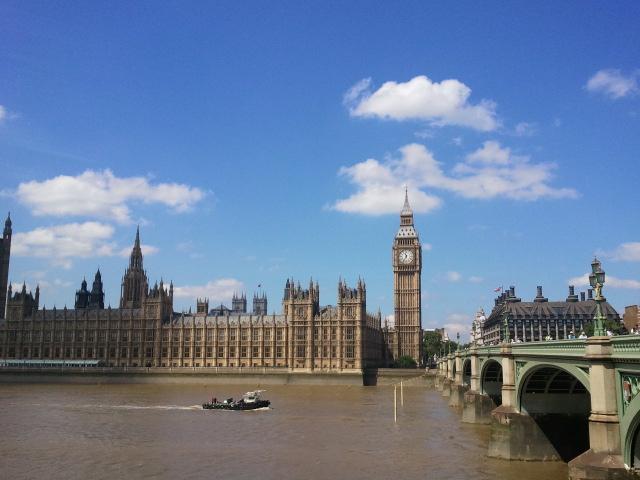What does Big Ben say?
Be succinct. 11:35. Are there any roads able to be seen?
Quick response, please. No. Is the boat heading to the bridge?
Quick response, please. Yes. Are the clouds visible?
Answer briefly. Yes. Is the sidewalk parallel to the river?
Quick response, please. No. 